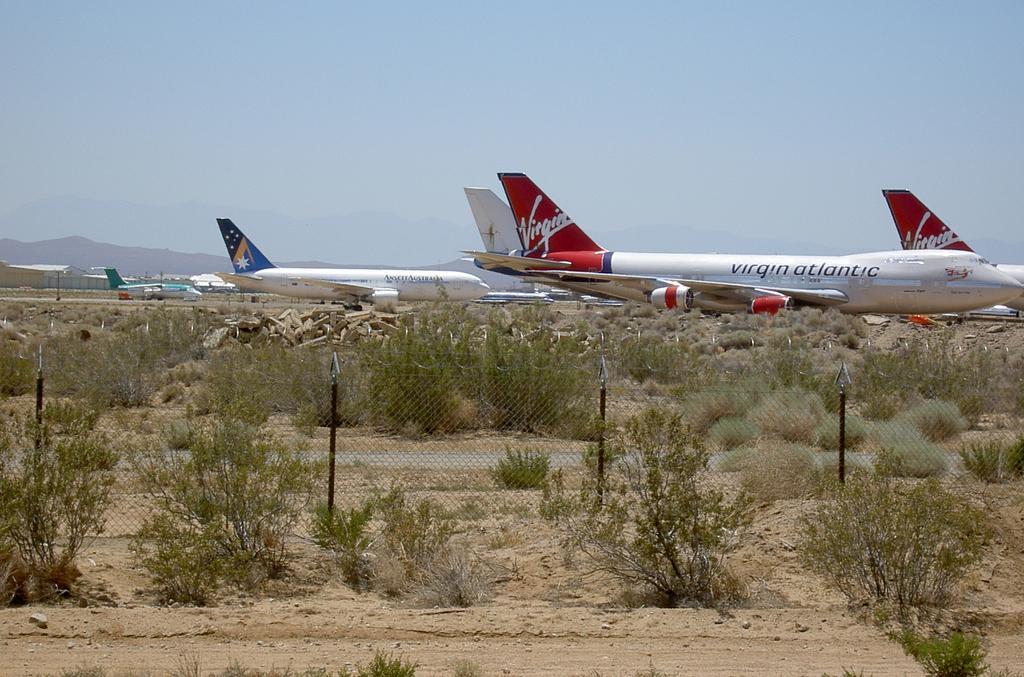Provide a one-sentence caption for the provided image. A fleet of red and white Virgin Atlantic airplanes parked on a runway in the desert. 